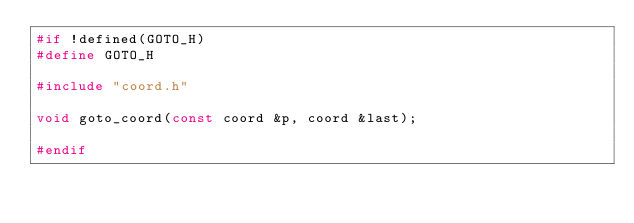Convert code to text. <code><loc_0><loc_0><loc_500><loc_500><_C_>#if !defined(GOTO_H)
#define GOTO_H

#include "coord.h"

void goto_coord(const coord &p, coord &last);

#endif
</code> 